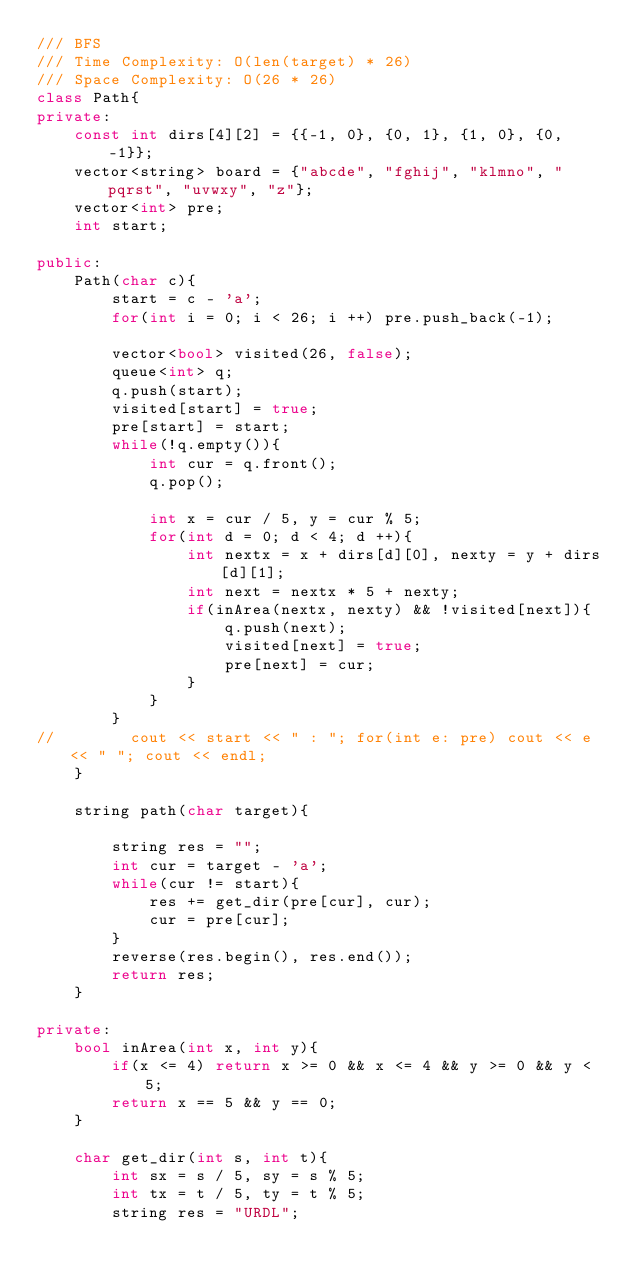Convert code to text. <code><loc_0><loc_0><loc_500><loc_500><_C++_>/// BFS
/// Time Complexity: O(len(target) * 26)
/// Space Complexity: O(26 * 26)
class Path{
private:
    const int dirs[4][2] = {{-1, 0}, {0, 1}, {1, 0}, {0, -1}};
    vector<string> board = {"abcde", "fghij", "klmno", "pqrst", "uvwxy", "z"};
    vector<int> pre;
    int start;

public:
    Path(char c){
        start = c - 'a';
        for(int i = 0; i < 26; i ++) pre.push_back(-1);

        vector<bool> visited(26, false);
        queue<int> q;
        q.push(start);
        visited[start] = true;
        pre[start] = start;
        while(!q.empty()){
            int cur = q.front();
            q.pop();

            int x = cur / 5, y = cur % 5;
            for(int d = 0; d < 4; d ++){
                int nextx = x + dirs[d][0], nexty = y + dirs[d][1];
                int next = nextx * 5 + nexty;
                if(inArea(nextx, nexty) && !visited[next]){
                    q.push(next);
                    visited[next] = true;
                    pre[next] = cur;
                }
            }
        }
//        cout << start << " : "; for(int e: pre) cout << e << " "; cout << endl;
    }

    string path(char target){

        string res = "";
        int cur = target - 'a';
        while(cur != start){
            res += get_dir(pre[cur], cur);
            cur = pre[cur];
        }
        reverse(res.begin(), res.end());
        return res;
    }

private:
    bool inArea(int x, int y){
        if(x <= 4) return x >= 0 && x <= 4 && y >= 0 && y < 5;
        return x == 5 && y == 0;
    }

    char get_dir(int s, int t){
        int sx = s / 5, sy = s % 5;
        int tx = t / 5, ty = t % 5;
        string res = "URDL";</code> 